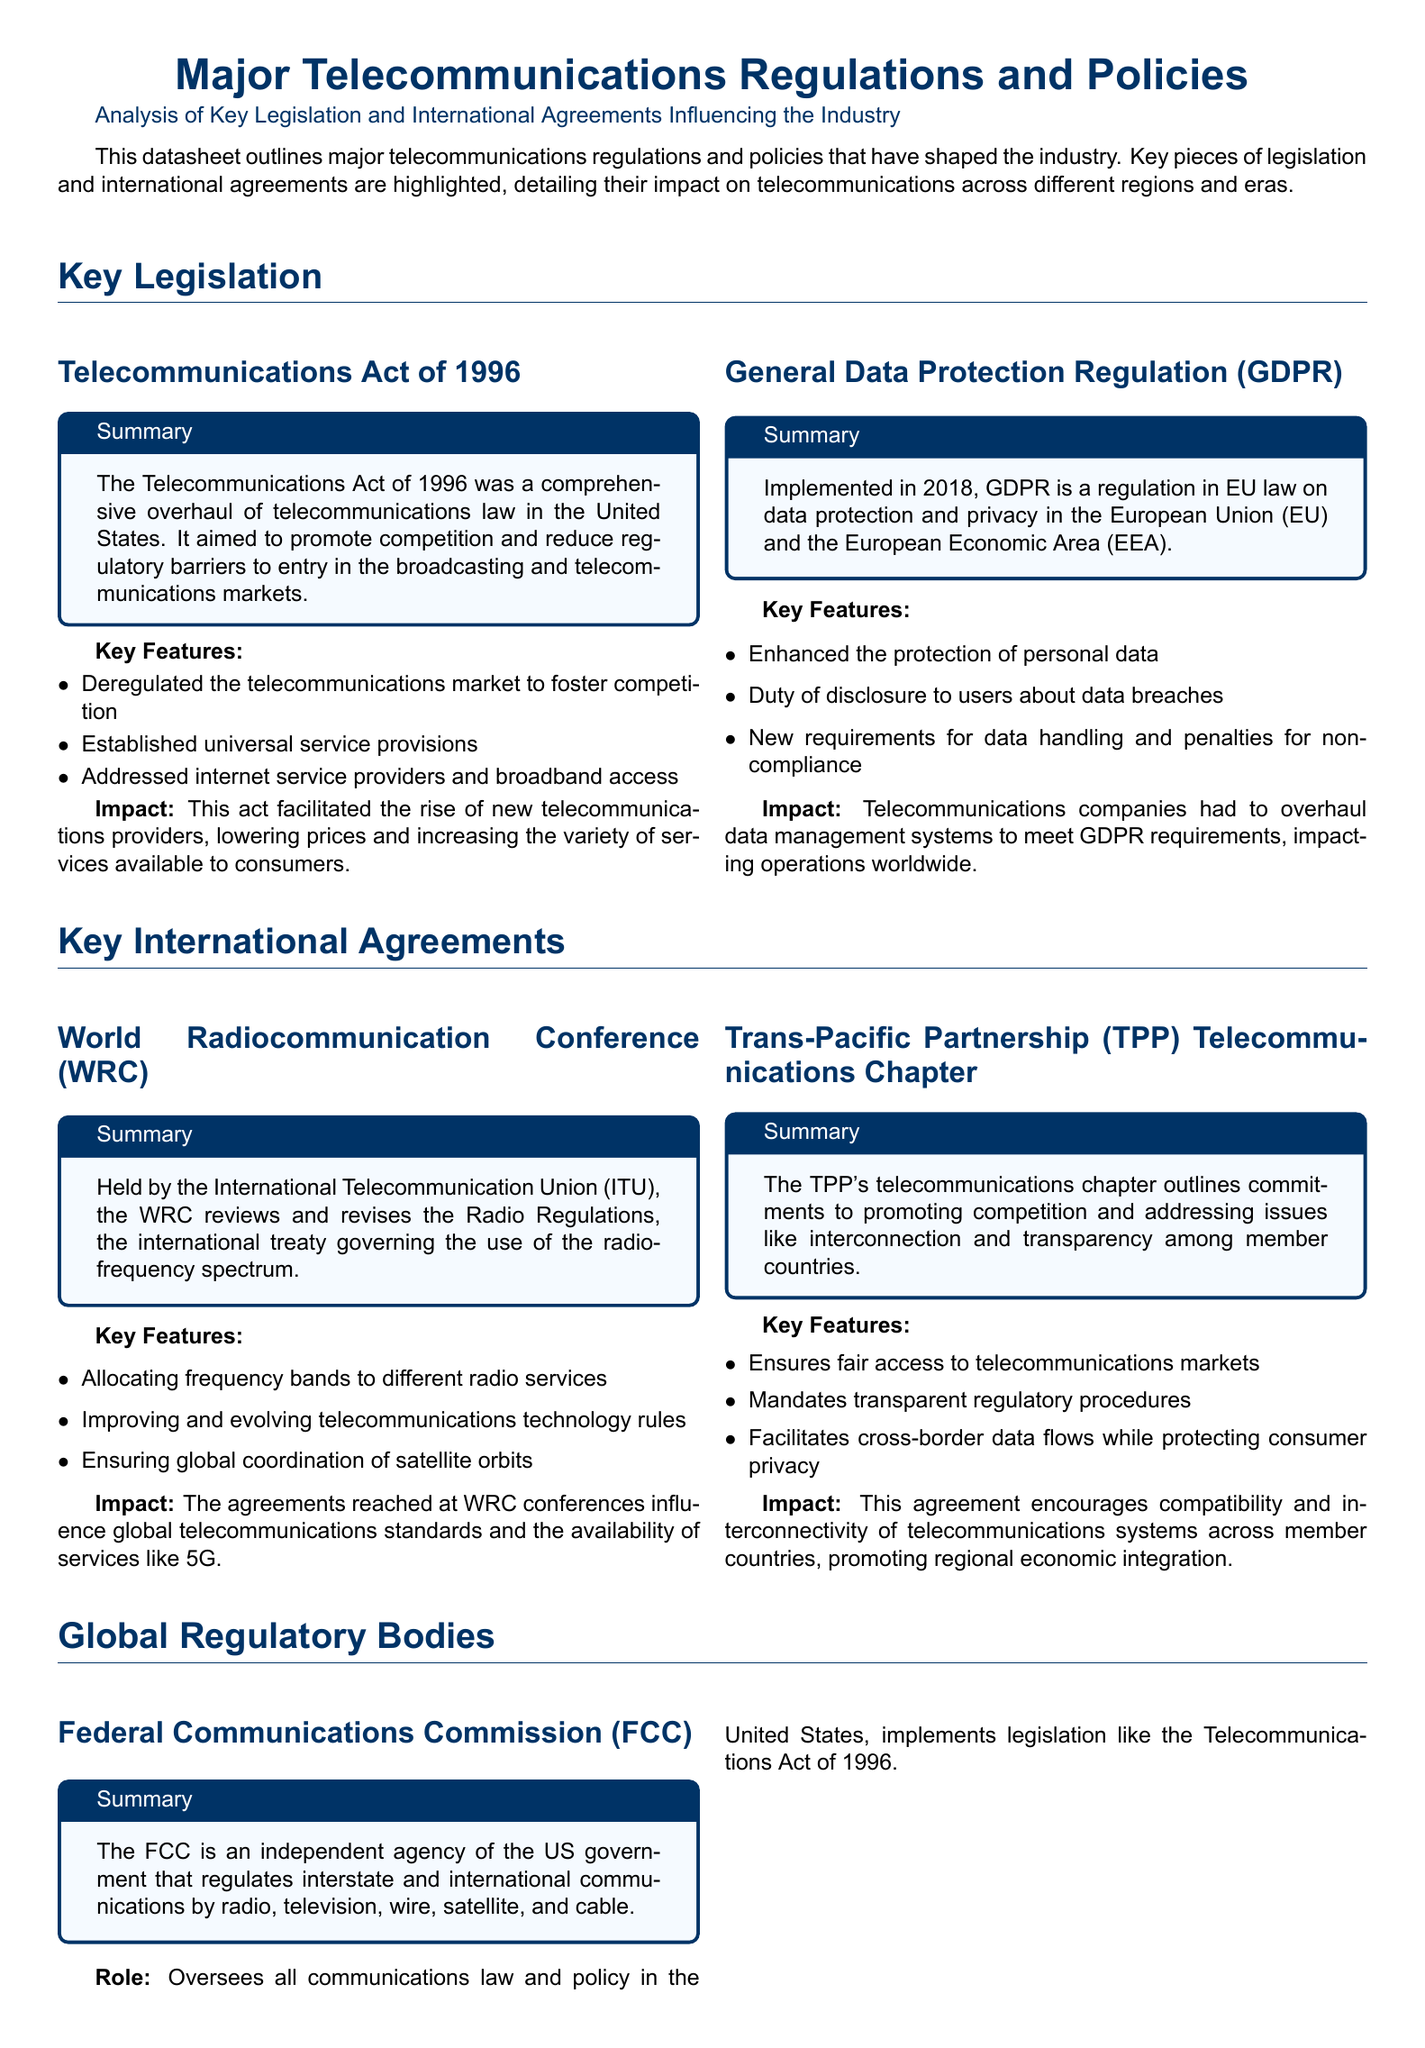What is the year the Telecommunications Act was enacted? The document mentions the Telecommunications Act of 1996 was a comprehensive overhaul of telecommunications law in the United States.
Answer: 1996 What does GDPR stand for? The document states that GDPR is a regulation in EU law on data protection, standing for General Data Protection Regulation.
Answer: General Data Protection Regulation What is the main purpose of the World Radiocommunication Conference? The document explains that the WRC reviews and revises the Radio Regulations, governing the use of the radio-frequency spectrum.
Answer: Revises Radio Regulations What does the TPP's telecommunications chapter promote? The document notes that the TPP telecommunications chapter promotes competition and addresses issues like interconnection and transparency.
Answer: Competition Which agency oversees communications law in the United States? The document identifies the Federal Communications Commission (FCC) as the independent agency regulating communications in the US.
Answer: Federal Communications Commission How often is the World Radiocommunication Conference held? The document does not specify frequency, but implies it is a regular event held by the ITU.
Answer: Regularly What significant changes did the GDPR introduce? The document lists key features of GDPR, including enhanced protection of personal data and duties of disclosure about data breaches.
Answer: Enhanced protection of personal data How does the TPP affect cross-border data flows? The document states that the TPP facilitates cross-border data flows while protecting consumer privacy.
Answer: Protects consumer privacy What global body allocates frequency bands for radio services? The document describes the International Telecommunication Union (ITU) as responsible for global connectivity and frequency allocation.
Answer: International Telecommunication Union 